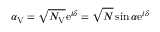Convert formula to latex. <formula><loc_0><loc_0><loc_500><loc_500>\alpha _ { V } = \sqrt { N _ { V } } e ^ { i \delta } = \sqrt { N } \sin \alpha e ^ { i \delta }</formula> 